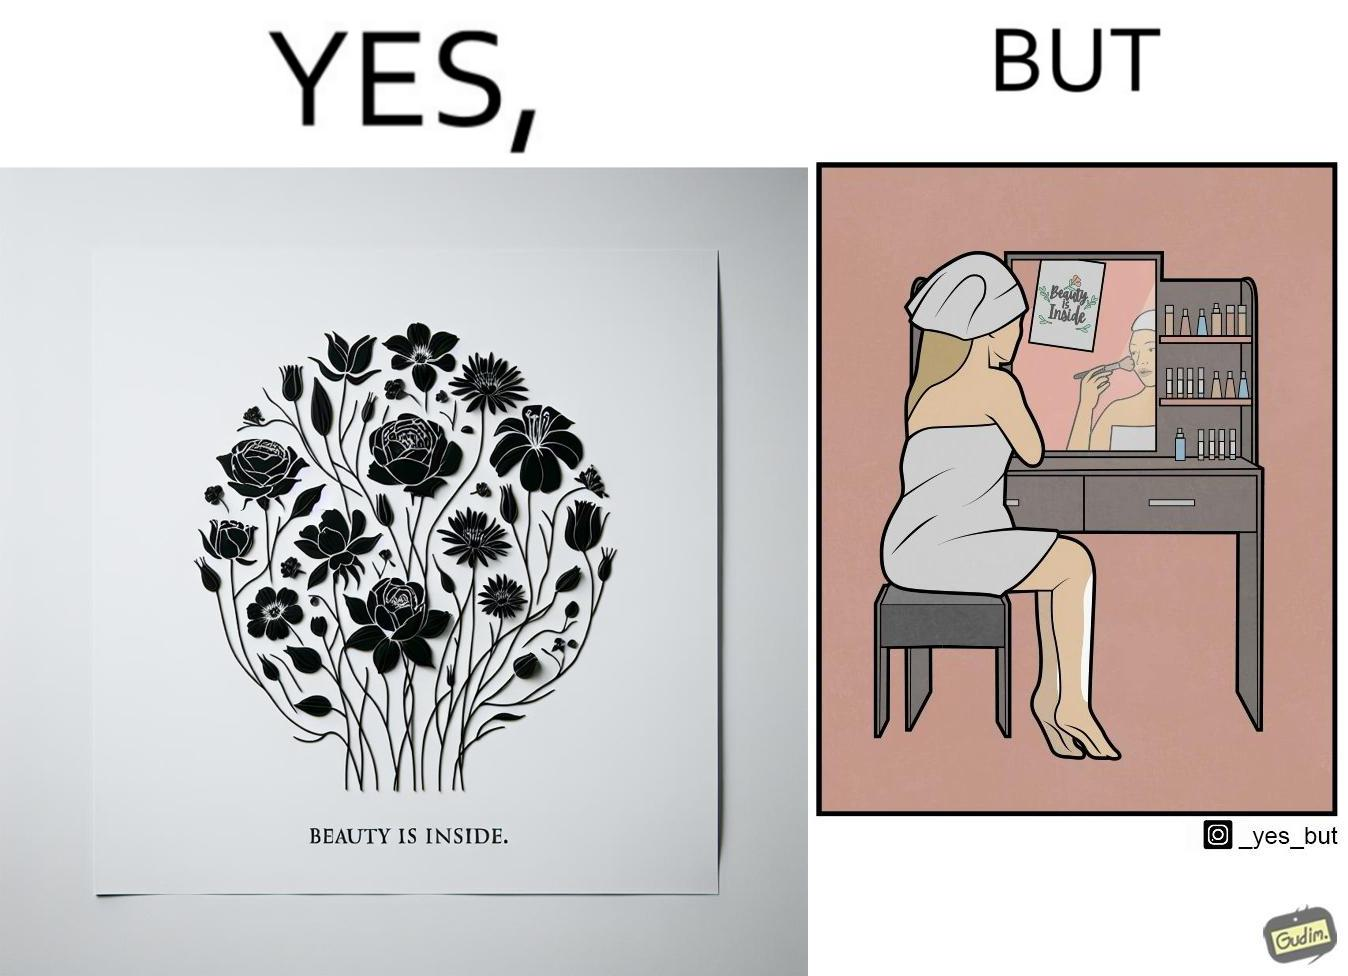Compare the left and right sides of this image. In the left part of the image: The image shows a text in beautiful font with flowers drawn around it. The text says "Beauty Is Inside". In the right part of the image: The image shows a woman applying makeup after shower by looking at herself in the dressing mirror. A piece of paper that says "Beauty is Inside" is clipped to the top of the mirror. 